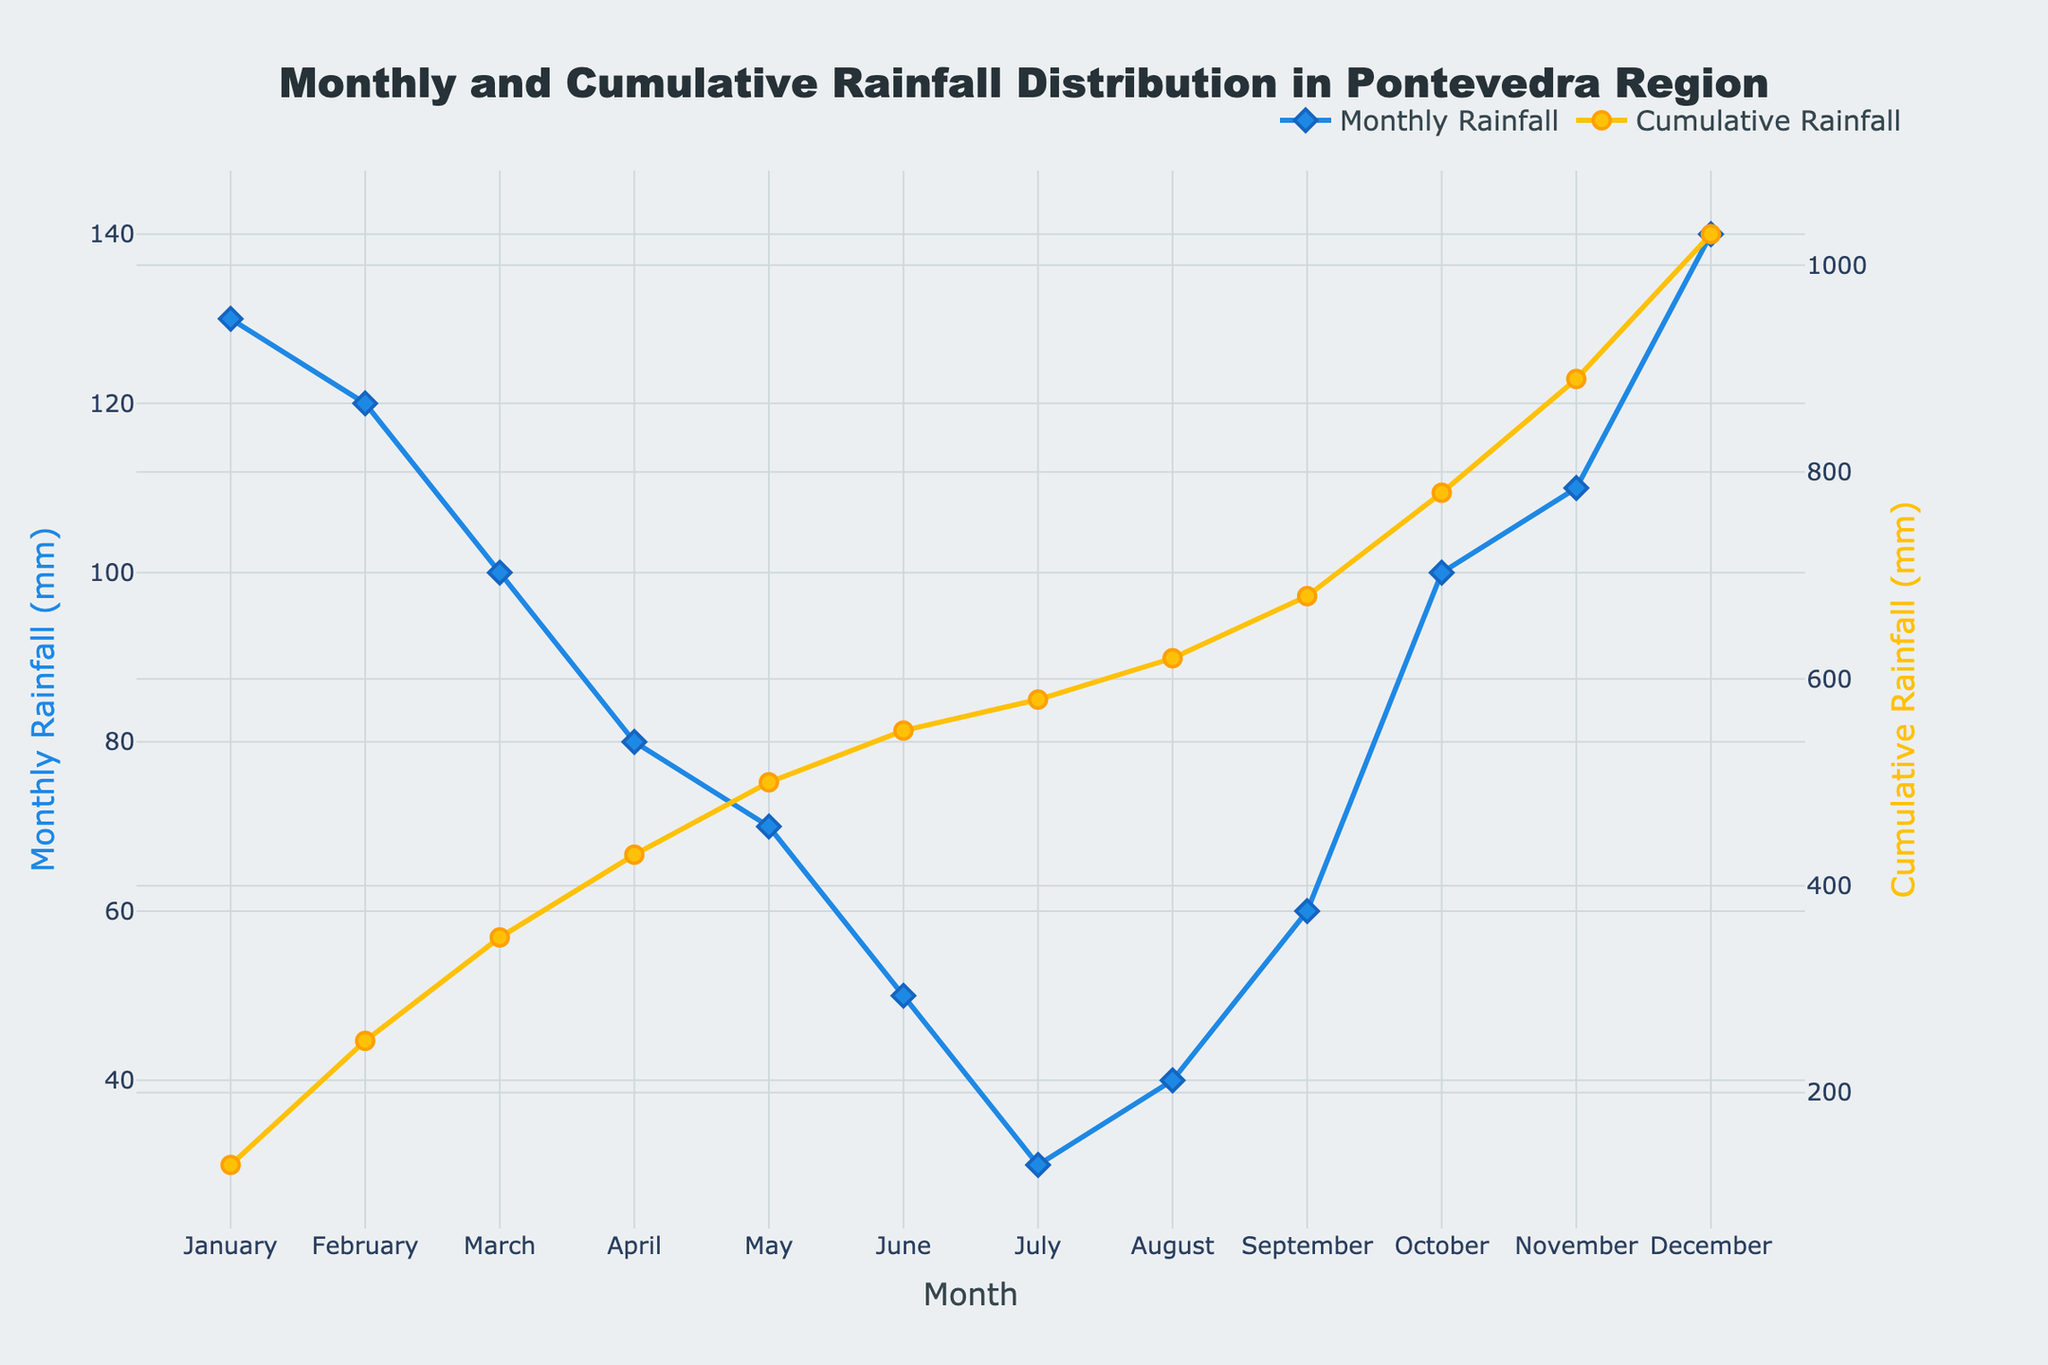What is the title of the plot? The title of the plot is placed at the top center and is written in large, bold font. It reads "Monthly and Cumulative Rainfall Distribution in Pontevedra Region".
Answer: Monthly and Cumulative Rainfall Distribution in Pontevedra Region What is the Monthly Rainfall in July? To find this, look at the point corresponding to July on the x-axis and refer to the value of the blue line (Monthly Rainfall), which is marked with a diamond symbol. The value is 30 mm.
Answer: 30 mm What is the difference in Monthly Rainfall between March and April? Refer to the Monthly Rainfall values on the plot for March and April. March has 100 mm and April has 80 mm. The difference is calculated as 100 mm - 80 mm = 20 mm.
Answer: 20 mm In which month did the Cumulative Rainfall first exceed 500 mm? Follow the orange line (Cumulative Rainfall) and identify the month where it first crosses the 500 mm mark. It exceeds 500 mm in May.
Answer: May Which month has the highest Monthly Rainfall, and what is its value? Find the highest point on the blue line (Monthly Rainfall). This highest point corresponds to December, where the rainfall is 140 mm.
Answer: December, 140 mm What are the cumulative rainfall values for June and December? Look at the points on the orange line corresponding to June and December. June has 550 mm of cumulative rainfall, and December has 1030 mm.
Answer: June: 550 mm, December: 1030 mm How much more rain fell in November compared to July? Identify the Monthly Rainfall for November and July from the plot. November has 110 mm and July has 30 mm. The difference is 110 mm - 30 mm = 80 mm.
Answer: 80 mm How many months had a Monthly Rainfall of 100 mm or more? Check the blue line (Monthly Rainfall) and count the number of markers that are at or above 100 mm. These months are January, February, March, October, November, and December, totaling 6 months.
Answer: 6 months Which two consecutive months show the smallest increase in Cumulative Rainfall? Look at the changes in the orange line (Cumulative Rainfall) and identify the two consecutive months with the least difference. The smallest increase is between July and August where the increase is 40 mm (580 mm to 620 mm).
Answer: July and August What is the average Monthly Rainfall over the year? Sum up all the Monthly Rainfall values and divide by 12 (the number of months). The values are 130 + 120 + 100 + 80 + 70 + 50 + 30 + 40 + 60 + 100 + 110 + 140 = 1030 mm. The average is 1030 / 12 = 85.83 mm.
Answer: 85.83 mm 